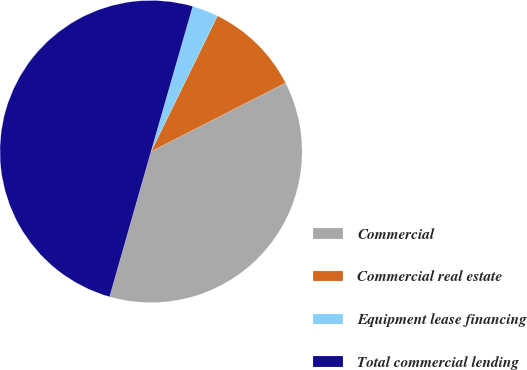Convert chart. <chart><loc_0><loc_0><loc_500><loc_500><pie_chart><fcel>Commercial<fcel>Commercial real estate<fcel>Equipment lease financing<fcel>Total commercial lending<nl><fcel>36.93%<fcel>10.24%<fcel>2.8%<fcel>50.03%<nl></chart> 